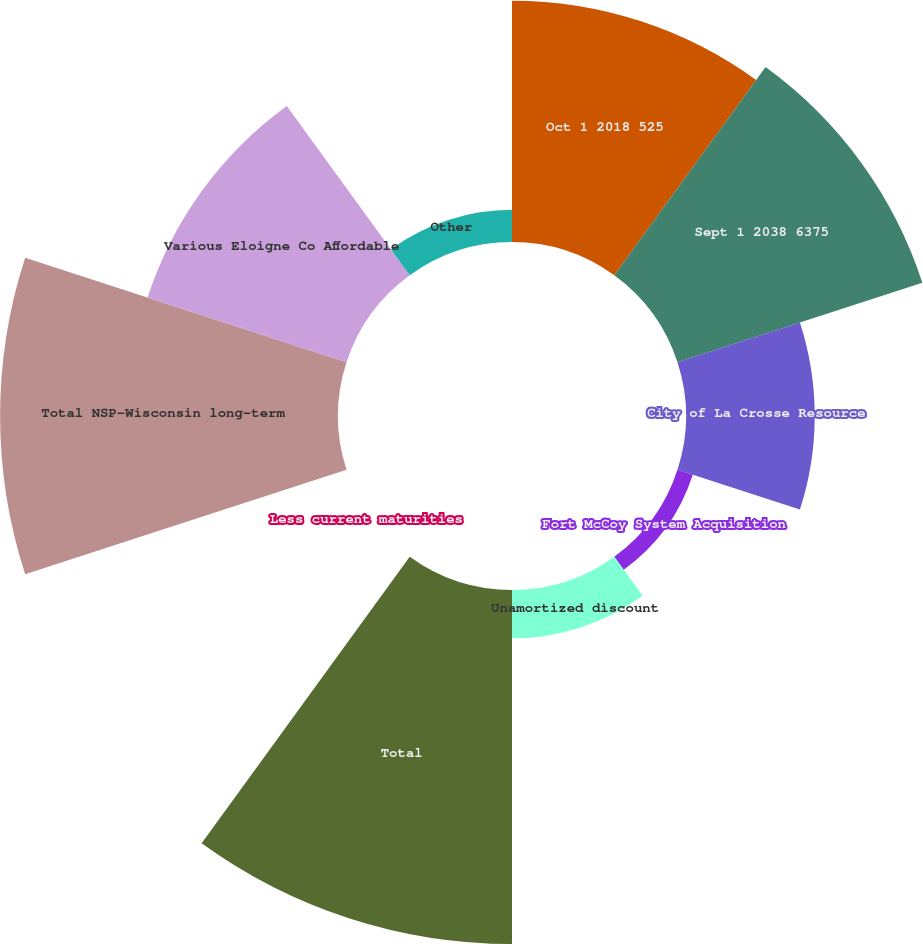<chart> <loc_0><loc_0><loc_500><loc_500><pie_chart><fcel>Oct 1 2018 525<fcel>Sept 1 2038 6375<fcel>City of La Crosse Resource<fcel>Fort McCoy System Acquisition<fcel>Unamortized discount<fcel>Total<fcel>Less current maturities<fcel>Total NSP-Wisconsin long-term<fcel>Various Eloigne Co Affordable<fcel>Other<nl><fcel>14.85%<fcel>15.84%<fcel>7.92%<fcel>0.99%<fcel>2.97%<fcel>21.78%<fcel>0.0%<fcel>20.79%<fcel>12.87%<fcel>1.98%<nl></chart> 